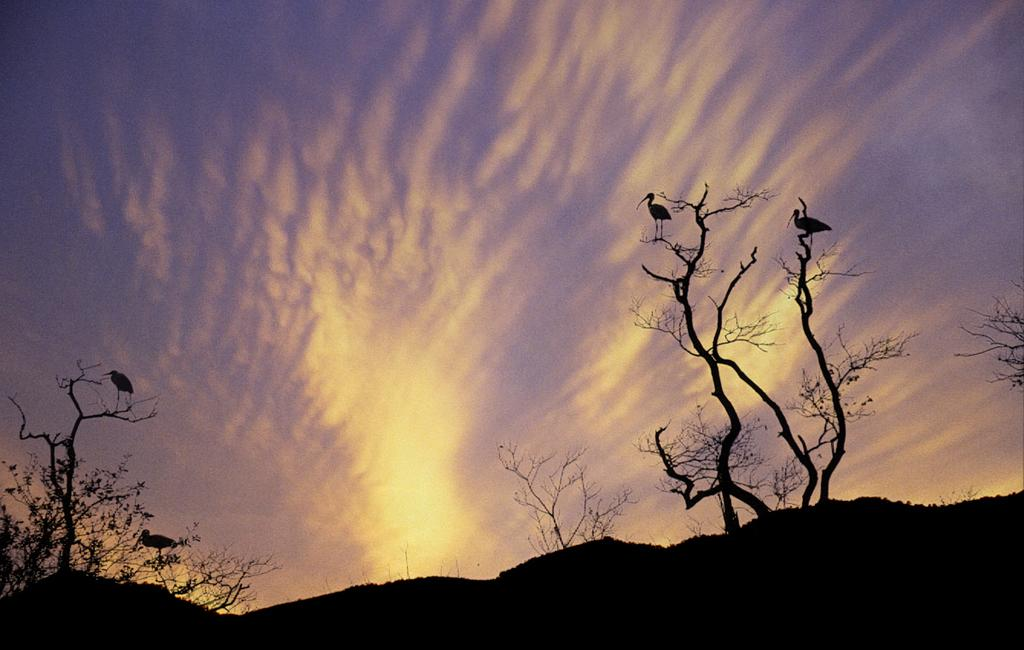How many birds can be seen in the image? There are three birds in the image. What is visible in the background of the image? The sky is visible in the image. Are there any weather-related features in the image? Yes, clouds are present in the image. What type of liquid can be seen flowing from the beaks of the birds in the image? There is no liquid flowing from the beaks of the birds in the image; the birds are simply perched or flying. 